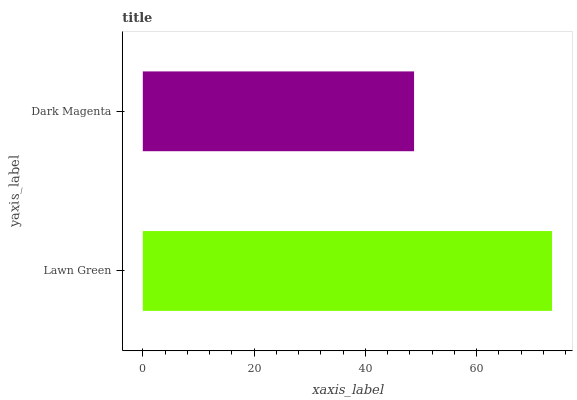Is Dark Magenta the minimum?
Answer yes or no. Yes. Is Lawn Green the maximum?
Answer yes or no. Yes. Is Dark Magenta the maximum?
Answer yes or no. No. Is Lawn Green greater than Dark Magenta?
Answer yes or no. Yes. Is Dark Magenta less than Lawn Green?
Answer yes or no. Yes. Is Dark Magenta greater than Lawn Green?
Answer yes or no. No. Is Lawn Green less than Dark Magenta?
Answer yes or no. No. Is Lawn Green the high median?
Answer yes or no. Yes. Is Dark Magenta the low median?
Answer yes or no. Yes. Is Dark Magenta the high median?
Answer yes or no. No. Is Lawn Green the low median?
Answer yes or no. No. 